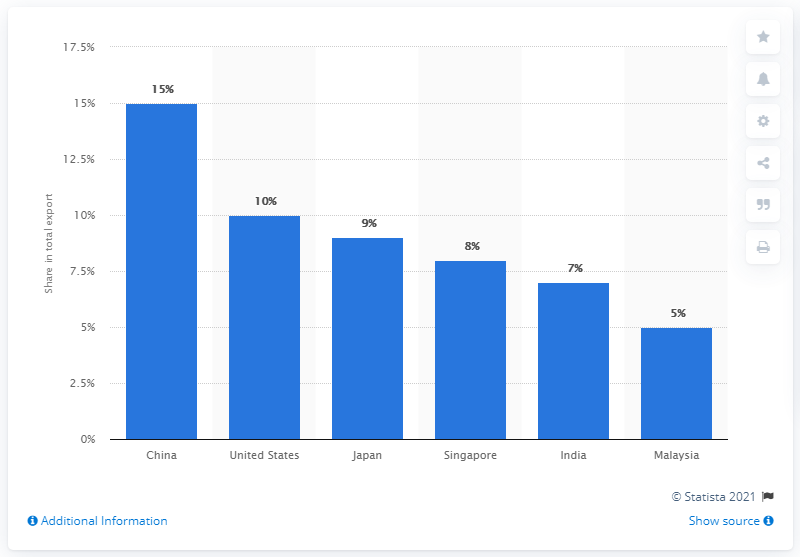Highlight a few significant elements in this photo. In 2019, Indonesia's most significant export partner was China. 